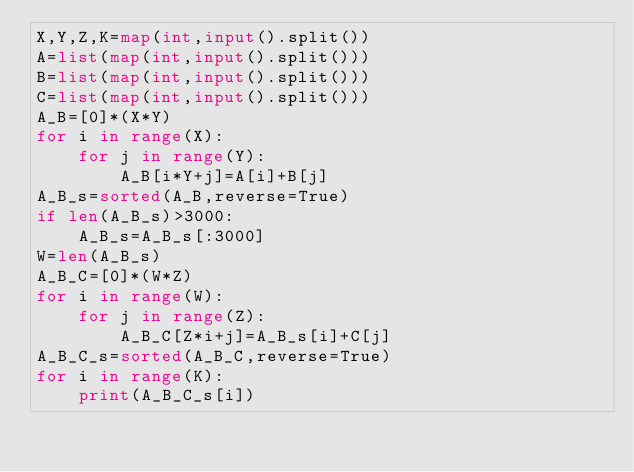<code> <loc_0><loc_0><loc_500><loc_500><_Python_>X,Y,Z,K=map(int,input().split())
A=list(map(int,input().split()))
B=list(map(int,input().split()))
C=list(map(int,input().split()))
A_B=[0]*(X*Y)
for i in range(X):
    for j in range(Y):
        A_B[i*Y+j]=A[i]+B[j]
A_B_s=sorted(A_B,reverse=True)
if len(A_B_s)>3000:
    A_B_s=A_B_s[:3000]
W=len(A_B_s)
A_B_C=[0]*(W*Z)
for i in range(W):
    for j in range(Z):
        A_B_C[Z*i+j]=A_B_s[i]+C[j]
A_B_C_s=sorted(A_B_C,reverse=True)
for i in range(K):
    print(A_B_C_s[i])</code> 